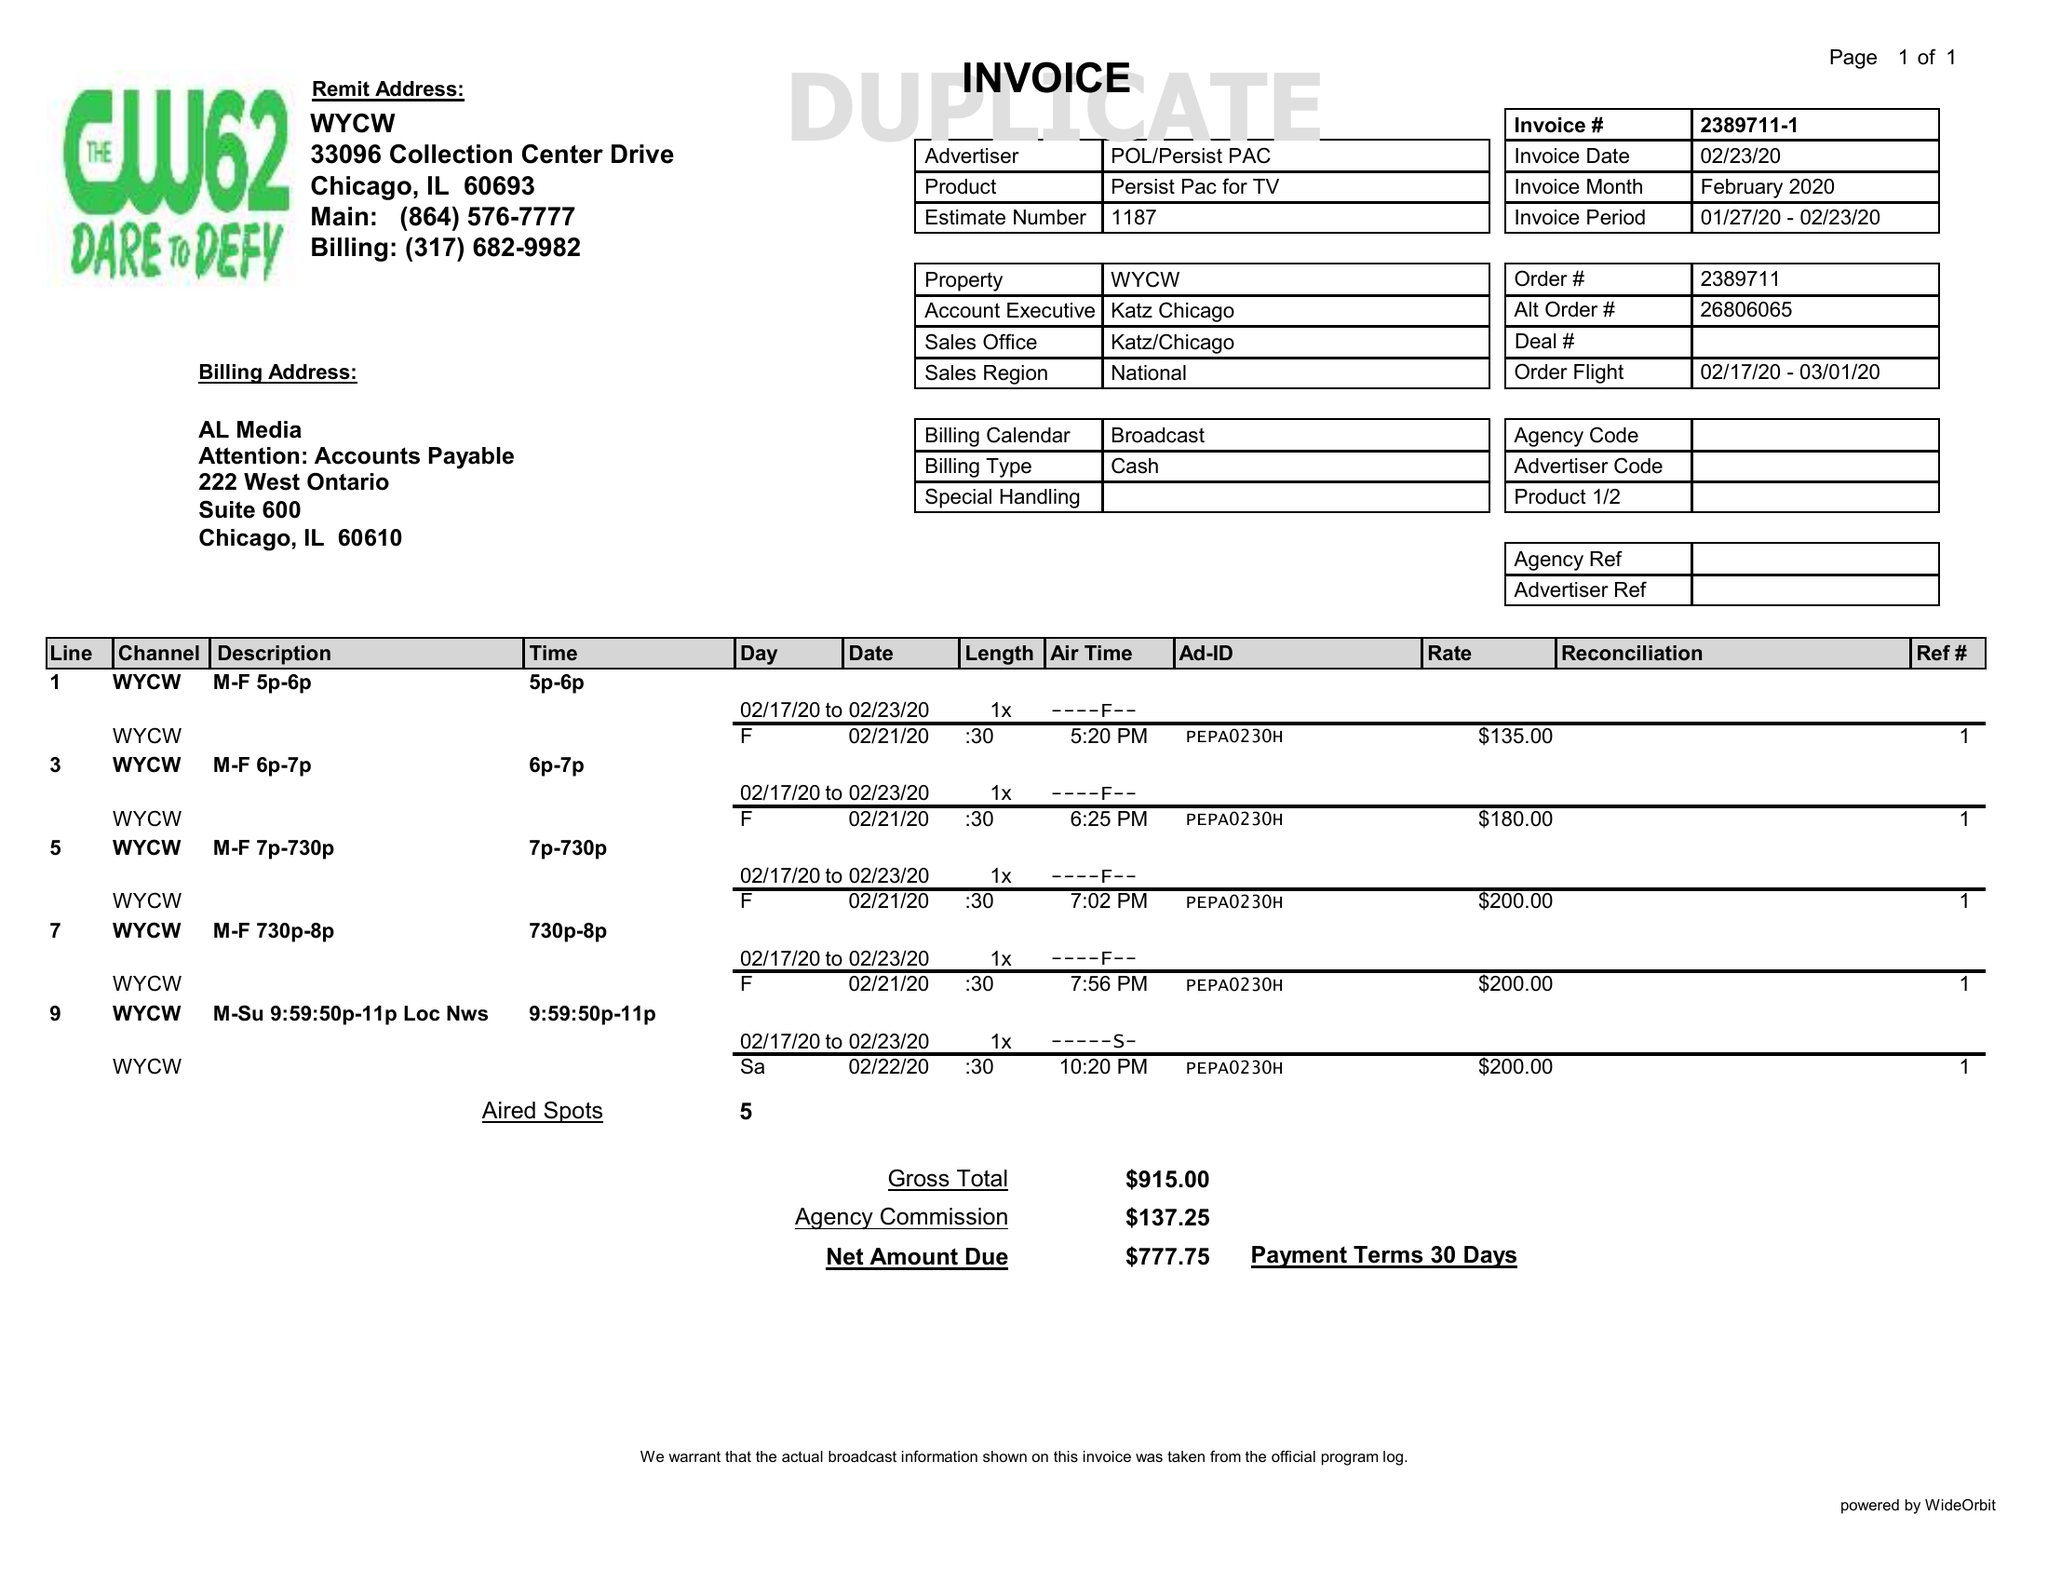What is the value for the flight_from?
Answer the question using a single word or phrase. 02/17/20 